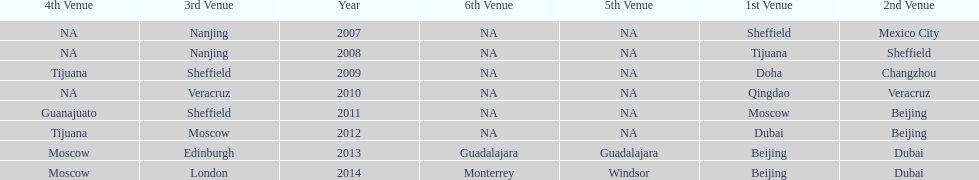Could you help me parse every detail presented in this table? {'header': ['4th Venue', '3rd Venue', 'Year', '6th Venue', '5th Venue', '1st Venue', '2nd Venue'], 'rows': [['NA', 'Nanjing', '2007', 'NA', 'NA', 'Sheffield', 'Mexico City'], ['NA', 'Nanjing', '2008', 'NA', 'NA', 'Tijuana', 'Sheffield'], ['Tijuana', 'Sheffield', '2009', 'NA', 'NA', 'Doha', 'Changzhou'], ['NA', 'Veracruz', '2010', 'NA', 'NA', 'Qingdao', 'Veracruz'], ['Guanajuato', 'Sheffield', '2011', 'NA', 'NA', 'Moscow', 'Beijing'], ['Tijuana', 'Moscow', '2012', 'NA', 'NA', 'Dubai', 'Beijing'], ['Moscow', 'Edinburgh', '2013', 'Guadalajara', 'Guadalajara', 'Beijing', 'Dubai'], ['Moscow', 'London', '2014', 'Monterrey', 'Windsor', 'Beijing', 'Dubai']]} Name a year whose second venue was the same as 2011. 2012. 